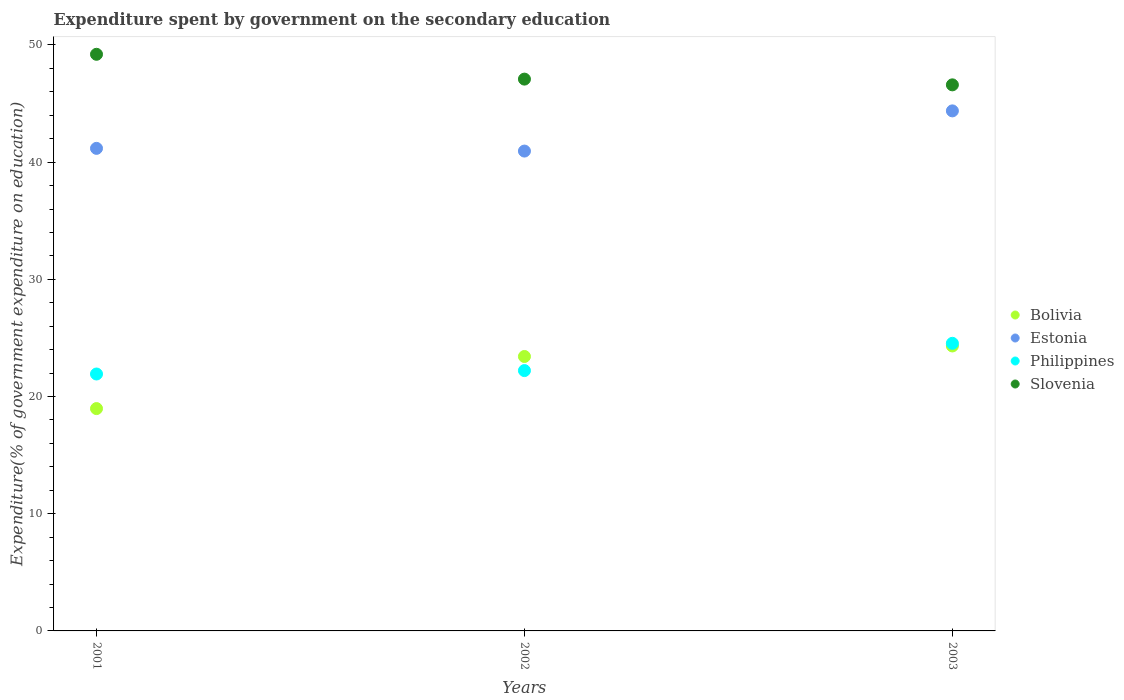How many different coloured dotlines are there?
Your answer should be compact. 4. Is the number of dotlines equal to the number of legend labels?
Your answer should be compact. Yes. What is the expenditure spent by government on the secondary education in Philippines in 2003?
Give a very brief answer. 24.54. Across all years, what is the maximum expenditure spent by government on the secondary education in Bolivia?
Keep it short and to the point. 24.32. Across all years, what is the minimum expenditure spent by government on the secondary education in Slovenia?
Your answer should be very brief. 46.59. In which year was the expenditure spent by government on the secondary education in Estonia maximum?
Your answer should be compact. 2003. What is the total expenditure spent by government on the secondary education in Slovenia in the graph?
Provide a short and direct response. 142.88. What is the difference between the expenditure spent by government on the secondary education in Philippines in 2001 and that in 2003?
Your answer should be very brief. -2.62. What is the difference between the expenditure spent by government on the secondary education in Estonia in 2002 and the expenditure spent by government on the secondary education in Slovenia in 2001?
Your answer should be compact. -8.26. What is the average expenditure spent by government on the secondary education in Bolivia per year?
Offer a very short reply. 22.23. In the year 2001, what is the difference between the expenditure spent by government on the secondary education in Bolivia and expenditure spent by government on the secondary education in Slovenia?
Your answer should be compact. -30.23. What is the ratio of the expenditure spent by government on the secondary education in Slovenia in 2001 to that in 2003?
Offer a very short reply. 1.06. Is the expenditure spent by government on the secondary education in Estonia in 2001 less than that in 2002?
Keep it short and to the point. No. What is the difference between the highest and the second highest expenditure spent by government on the secondary education in Estonia?
Your answer should be very brief. 3.2. What is the difference between the highest and the lowest expenditure spent by government on the secondary education in Bolivia?
Offer a terse response. 5.34. Is it the case that in every year, the sum of the expenditure spent by government on the secondary education in Philippines and expenditure spent by government on the secondary education in Bolivia  is greater than the expenditure spent by government on the secondary education in Slovenia?
Give a very brief answer. No. Does the expenditure spent by government on the secondary education in Slovenia monotonically increase over the years?
Your response must be concise. No. Is the expenditure spent by government on the secondary education in Estonia strictly less than the expenditure spent by government on the secondary education in Slovenia over the years?
Ensure brevity in your answer.  Yes. How many years are there in the graph?
Your response must be concise. 3. What is the difference between two consecutive major ticks on the Y-axis?
Give a very brief answer. 10. Does the graph contain any zero values?
Offer a terse response. No. Does the graph contain grids?
Your response must be concise. No. What is the title of the graph?
Offer a very short reply. Expenditure spent by government on the secondary education. Does "Austria" appear as one of the legend labels in the graph?
Ensure brevity in your answer.  No. What is the label or title of the Y-axis?
Offer a terse response. Expenditure(% of government expenditure on education). What is the Expenditure(% of government expenditure on education) in Bolivia in 2001?
Provide a short and direct response. 18.97. What is the Expenditure(% of government expenditure on education) of Estonia in 2001?
Make the answer very short. 41.18. What is the Expenditure(% of government expenditure on education) of Philippines in 2001?
Provide a succinct answer. 21.92. What is the Expenditure(% of government expenditure on education) of Slovenia in 2001?
Your response must be concise. 49.2. What is the Expenditure(% of government expenditure on education) in Bolivia in 2002?
Give a very brief answer. 23.42. What is the Expenditure(% of government expenditure on education) of Estonia in 2002?
Make the answer very short. 40.94. What is the Expenditure(% of government expenditure on education) in Philippines in 2002?
Ensure brevity in your answer.  22.21. What is the Expenditure(% of government expenditure on education) in Slovenia in 2002?
Provide a short and direct response. 47.08. What is the Expenditure(% of government expenditure on education) of Bolivia in 2003?
Make the answer very short. 24.32. What is the Expenditure(% of government expenditure on education) in Estonia in 2003?
Offer a very short reply. 44.37. What is the Expenditure(% of government expenditure on education) of Philippines in 2003?
Offer a very short reply. 24.54. What is the Expenditure(% of government expenditure on education) in Slovenia in 2003?
Your response must be concise. 46.59. Across all years, what is the maximum Expenditure(% of government expenditure on education) in Bolivia?
Keep it short and to the point. 24.32. Across all years, what is the maximum Expenditure(% of government expenditure on education) of Estonia?
Your answer should be very brief. 44.37. Across all years, what is the maximum Expenditure(% of government expenditure on education) of Philippines?
Keep it short and to the point. 24.54. Across all years, what is the maximum Expenditure(% of government expenditure on education) of Slovenia?
Give a very brief answer. 49.2. Across all years, what is the minimum Expenditure(% of government expenditure on education) of Bolivia?
Ensure brevity in your answer.  18.97. Across all years, what is the minimum Expenditure(% of government expenditure on education) of Estonia?
Make the answer very short. 40.94. Across all years, what is the minimum Expenditure(% of government expenditure on education) in Philippines?
Your response must be concise. 21.92. Across all years, what is the minimum Expenditure(% of government expenditure on education) of Slovenia?
Give a very brief answer. 46.59. What is the total Expenditure(% of government expenditure on education) of Bolivia in the graph?
Your answer should be compact. 66.7. What is the total Expenditure(% of government expenditure on education) of Estonia in the graph?
Ensure brevity in your answer.  126.49. What is the total Expenditure(% of government expenditure on education) in Philippines in the graph?
Your answer should be very brief. 68.68. What is the total Expenditure(% of government expenditure on education) in Slovenia in the graph?
Provide a short and direct response. 142.88. What is the difference between the Expenditure(% of government expenditure on education) in Bolivia in 2001 and that in 2002?
Provide a short and direct response. -4.45. What is the difference between the Expenditure(% of government expenditure on education) of Estonia in 2001 and that in 2002?
Give a very brief answer. 0.23. What is the difference between the Expenditure(% of government expenditure on education) in Philippines in 2001 and that in 2002?
Make the answer very short. -0.29. What is the difference between the Expenditure(% of government expenditure on education) in Slovenia in 2001 and that in 2002?
Offer a terse response. 2.12. What is the difference between the Expenditure(% of government expenditure on education) in Bolivia in 2001 and that in 2003?
Offer a terse response. -5.34. What is the difference between the Expenditure(% of government expenditure on education) in Estonia in 2001 and that in 2003?
Offer a very short reply. -3.2. What is the difference between the Expenditure(% of government expenditure on education) of Philippines in 2001 and that in 2003?
Make the answer very short. -2.62. What is the difference between the Expenditure(% of government expenditure on education) in Slovenia in 2001 and that in 2003?
Your response must be concise. 2.61. What is the difference between the Expenditure(% of government expenditure on education) in Bolivia in 2002 and that in 2003?
Your answer should be very brief. -0.9. What is the difference between the Expenditure(% of government expenditure on education) of Estonia in 2002 and that in 2003?
Make the answer very short. -3.43. What is the difference between the Expenditure(% of government expenditure on education) in Philippines in 2002 and that in 2003?
Provide a short and direct response. -2.33. What is the difference between the Expenditure(% of government expenditure on education) in Slovenia in 2002 and that in 2003?
Offer a terse response. 0.49. What is the difference between the Expenditure(% of government expenditure on education) of Bolivia in 2001 and the Expenditure(% of government expenditure on education) of Estonia in 2002?
Offer a terse response. -21.97. What is the difference between the Expenditure(% of government expenditure on education) of Bolivia in 2001 and the Expenditure(% of government expenditure on education) of Philippines in 2002?
Make the answer very short. -3.24. What is the difference between the Expenditure(% of government expenditure on education) in Bolivia in 2001 and the Expenditure(% of government expenditure on education) in Slovenia in 2002?
Your response must be concise. -28.11. What is the difference between the Expenditure(% of government expenditure on education) of Estonia in 2001 and the Expenditure(% of government expenditure on education) of Philippines in 2002?
Your response must be concise. 18.96. What is the difference between the Expenditure(% of government expenditure on education) in Estonia in 2001 and the Expenditure(% of government expenditure on education) in Slovenia in 2002?
Offer a very short reply. -5.91. What is the difference between the Expenditure(% of government expenditure on education) of Philippines in 2001 and the Expenditure(% of government expenditure on education) of Slovenia in 2002?
Keep it short and to the point. -25.16. What is the difference between the Expenditure(% of government expenditure on education) of Bolivia in 2001 and the Expenditure(% of government expenditure on education) of Estonia in 2003?
Keep it short and to the point. -25.4. What is the difference between the Expenditure(% of government expenditure on education) of Bolivia in 2001 and the Expenditure(% of government expenditure on education) of Philippines in 2003?
Your answer should be very brief. -5.57. What is the difference between the Expenditure(% of government expenditure on education) in Bolivia in 2001 and the Expenditure(% of government expenditure on education) in Slovenia in 2003?
Your answer should be compact. -27.62. What is the difference between the Expenditure(% of government expenditure on education) in Estonia in 2001 and the Expenditure(% of government expenditure on education) in Philippines in 2003?
Provide a succinct answer. 16.64. What is the difference between the Expenditure(% of government expenditure on education) of Estonia in 2001 and the Expenditure(% of government expenditure on education) of Slovenia in 2003?
Provide a succinct answer. -5.42. What is the difference between the Expenditure(% of government expenditure on education) of Philippines in 2001 and the Expenditure(% of government expenditure on education) of Slovenia in 2003?
Your response must be concise. -24.67. What is the difference between the Expenditure(% of government expenditure on education) of Bolivia in 2002 and the Expenditure(% of government expenditure on education) of Estonia in 2003?
Ensure brevity in your answer.  -20.96. What is the difference between the Expenditure(% of government expenditure on education) in Bolivia in 2002 and the Expenditure(% of government expenditure on education) in Philippines in 2003?
Provide a short and direct response. -1.12. What is the difference between the Expenditure(% of government expenditure on education) of Bolivia in 2002 and the Expenditure(% of government expenditure on education) of Slovenia in 2003?
Offer a very short reply. -23.18. What is the difference between the Expenditure(% of government expenditure on education) in Estonia in 2002 and the Expenditure(% of government expenditure on education) in Philippines in 2003?
Offer a very short reply. 16.4. What is the difference between the Expenditure(% of government expenditure on education) of Estonia in 2002 and the Expenditure(% of government expenditure on education) of Slovenia in 2003?
Offer a very short reply. -5.65. What is the difference between the Expenditure(% of government expenditure on education) in Philippines in 2002 and the Expenditure(% of government expenditure on education) in Slovenia in 2003?
Your answer should be very brief. -24.38. What is the average Expenditure(% of government expenditure on education) of Bolivia per year?
Provide a succinct answer. 22.23. What is the average Expenditure(% of government expenditure on education) of Estonia per year?
Offer a terse response. 42.16. What is the average Expenditure(% of government expenditure on education) in Philippines per year?
Provide a short and direct response. 22.89. What is the average Expenditure(% of government expenditure on education) in Slovenia per year?
Provide a succinct answer. 47.63. In the year 2001, what is the difference between the Expenditure(% of government expenditure on education) of Bolivia and Expenditure(% of government expenditure on education) of Estonia?
Give a very brief answer. -22.2. In the year 2001, what is the difference between the Expenditure(% of government expenditure on education) in Bolivia and Expenditure(% of government expenditure on education) in Philippines?
Your response must be concise. -2.95. In the year 2001, what is the difference between the Expenditure(% of government expenditure on education) in Bolivia and Expenditure(% of government expenditure on education) in Slovenia?
Give a very brief answer. -30.23. In the year 2001, what is the difference between the Expenditure(% of government expenditure on education) in Estonia and Expenditure(% of government expenditure on education) in Philippines?
Provide a short and direct response. 19.25. In the year 2001, what is the difference between the Expenditure(% of government expenditure on education) of Estonia and Expenditure(% of government expenditure on education) of Slovenia?
Offer a terse response. -8.03. In the year 2001, what is the difference between the Expenditure(% of government expenditure on education) in Philippines and Expenditure(% of government expenditure on education) in Slovenia?
Ensure brevity in your answer.  -27.28. In the year 2002, what is the difference between the Expenditure(% of government expenditure on education) of Bolivia and Expenditure(% of government expenditure on education) of Estonia?
Ensure brevity in your answer.  -17.53. In the year 2002, what is the difference between the Expenditure(% of government expenditure on education) in Bolivia and Expenditure(% of government expenditure on education) in Philippines?
Your answer should be very brief. 1.2. In the year 2002, what is the difference between the Expenditure(% of government expenditure on education) of Bolivia and Expenditure(% of government expenditure on education) of Slovenia?
Make the answer very short. -23.67. In the year 2002, what is the difference between the Expenditure(% of government expenditure on education) in Estonia and Expenditure(% of government expenditure on education) in Philippines?
Provide a short and direct response. 18.73. In the year 2002, what is the difference between the Expenditure(% of government expenditure on education) of Estonia and Expenditure(% of government expenditure on education) of Slovenia?
Give a very brief answer. -6.14. In the year 2002, what is the difference between the Expenditure(% of government expenditure on education) in Philippines and Expenditure(% of government expenditure on education) in Slovenia?
Give a very brief answer. -24.87. In the year 2003, what is the difference between the Expenditure(% of government expenditure on education) in Bolivia and Expenditure(% of government expenditure on education) in Estonia?
Your response must be concise. -20.06. In the year 2003, what is the difference between the Expenditure(% of government expenditure on education) in Bolivia and Expenditure(% of government expenditure on education) in Philippines?
Make the answer very short. -0.23. In the year 2003, what is the difference between the Expenditure(% of government expenditure on education) in Bolivia and Expenditure(% of government expenditure on education) in Slovenia?
Provide a short and direct response. -22.28. In the year 2003, what is the difference between the Expenditure(% of government expenditure on education) in Estonia and Expenditure(% of government expenditure on education) in Philippines?
Offer a terse response. 19.83. In the year 2003, what is the difference between the Expenditure(% of government expenditure on education) in Estonia and Expenditure(% of government expenditure on education) in Slovenia?
Your response must be concise. -2.22. In the year 2003, what is the difference between the Expenditure(% of government expenditure on education) of Philippines and Expenditure(% of government expenditure on education) of Slovenia?
Provide a short and direct response. -22.05. What is the ratio of the Expenditure(% of government expenditure on education) of Bolivia in 2001 to that in 2002?
Your answer should be compact. 0.81. What is the ratio of the Expenditure(% of government expenditure on education) of Estonia in 2001 to that in 2002?
Your response must be concise. 1.01. What is the ratio of the Expenditure(% of government expenditure on education) in Philippines in 2001 to that in 2002?
Your answer should be compact. 0.99. What is the ratio of the Expenditure(% of government expenditure on education) in Slovenia in 2001 to that in 2002?
Provide a short and direct response. 1.04. What is the ratio of the Expenditure(% of government expenditure on education) of Bolivia in 2001 to that in 2003?
Provide a succinct answer. 0.78. What is the ratio of the Expenditure(% of government expenditure on education) in Estonia in 2001 to that in 2003?
Keep it short and to the point. 0.93. What is the ratio of the Expenditure(% of government expenditure on education) in Philippines in 2001 to that in 2003?
Offer a terse response. 0.89. What is the ratio of the Expenditure(% of government expenditure on education) of Slovenia in 2001 to that in 2003?
Your answer should be very brief. 1.06. What is the ratio of the Expenditure(% of government expenditure on education) in Bolivia in 2002 to that in 2003?
Ensure brevity in your answer.  0.96. What is the ratio of the Expenditure(% of government expenditure on education) of Estonia in 2002 to that in 2003?
Offer a terse response. 0.92. What is the ratio of the Expenditure(% of government expenditure on education) in Philippines in 2002 to that in 2003?
Ensure brevity in your answer.  0.91. What is the ratio of the Expenditure(% of government expenditure on education) of Slovenia in 2002 to that in 2003?
Make the answer very short. 1.01. What is the difference between the highest and the second highest Expenditure(% of government expenditure on education) of Bolivia?
Your answer should be compact. 0.9. What is the difference between the highest and the second highest Expenditure(% of government expenditure on education) in Estonia?
Ensure brevity in your answer.  3.2. What is the difference between the highest and the second highest Expenditure(% of government expenditure on education) of Philippines?
Provide a short and direct response. 2.33. What is the difference between the highest and the second highest Expenditure(% of government expenditure on education) in Slovenia?
Your answer should be very brief. 2.12. What is the difference between the highest and the lowest Expenditure(% of government expenditure on education) in Bolivia?
Your response must be concise. 5.34. What is the difference between the highest and the lowest Expenditure(% of government expenditure on education) in Estonia?
Keep it short and to the point. 3.43. What is the difference between the highest and the lowest Expenditure(% of government expenditure on education) of Philippines?
Provide a short and direct response. 2.62. What is the difference between the highest and the lowest Expenditure(% of government expenditure on education) in Slovenia?
Offer a terse response. 2.61. 